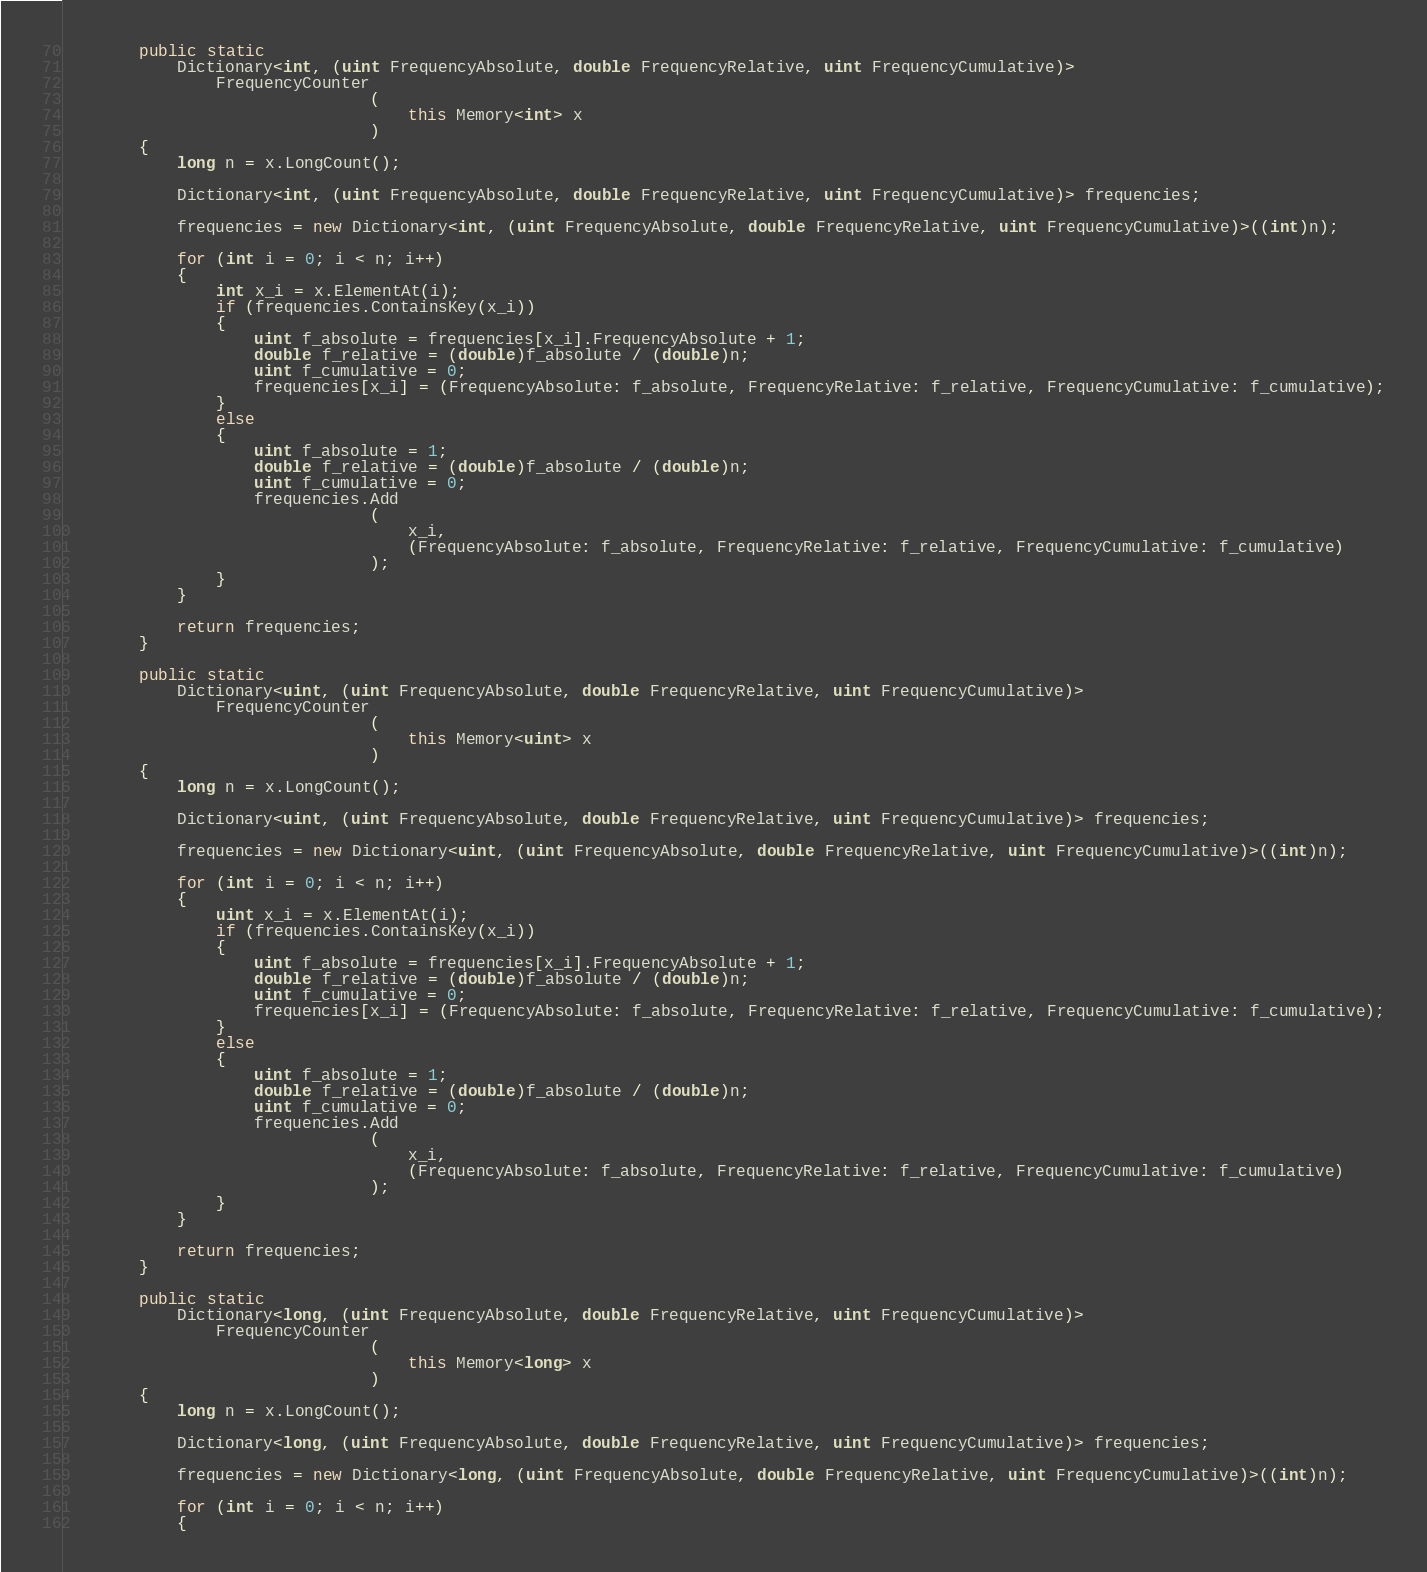Convert code to text. <code><loc_0><loc_0><loc_500><loc_500><_C#_>        public static
            Dictionary<int, (uint FrequencyAbsolute, double FrequencyRelative, uint FrequencyCumulative)>
                FrequencyCounter
                                (
                                    this Memory<int> x
                                )
        {
            long n = x.LongCount();

            Dictionary<int, (uint FrequencyAbsolute, double FrequencyRelative, uint FrequencyCumulative)> frequencies;

            frequencies = new Dictionary<int, (uint FrequencyAbsolute, double FrequencyRelative, uint FrequencyCumulative)>((int)n);

            for (int i = 0; i < n; i++)
            {
                int x_i = x.ElementAt(i);
                if (frequencies.ContainsKey(x_i))
                {
                    uint f_absolute = frequencies[x_i].FrequencyAbsolute + 1;
                    double f_relative = (double)f_absolute / (double)n;
                    uint f_cumulative = 0;
                    frequencies[x_i] = (FrequencyAbsolute: f_absolute, FrequencyRelative: f_relative, FrequencyCumulative: f_cumulative);
                }
                else
                {
                    uint f_absolute = 1;
                    double f_relative = (double)f_absolute / (double)n;
                    uint f_cumulative = 0;
                    frequencies.Add
                                (
                                    x_i,
                                    (FrequencyAbsolute: f_absolute, FrequencyRelative: f_relative, FrequencyCumulative: f_cumulative)
                                );
                }
            }

            return frequencies;
        }

        public static
            Dictionary<uint, (uint FrequencyAbsolute, double FrequencyRelative, uint FrequencyCumulative)>
                FrequencyCounter
                                (
                                    this Memory<uint> x
                                )
        {
            long n = x.LongCount();

            Dictionary<uint, (uint FrequencyAbsolute, double FrequencyRelative, uint FrequencyCumulative)> frequencies;

            frequencies = new Dictionary<uint, (uint FrequencyAbsolute, double FrequencyRelative, uint FrequencyCumulative)>((int)n);

            for (int i = 0; i < n; i++)
            {
                uint x_i = x.ElementAt(i);
                if (frequencies.ContainsKey(x_i))
                {
                    uint f_absolute = frequencies[x_i].FrequencyAbsolute + 1;
                    double f_relative = (double)f_absolute / (double)n;
                    uint f_cumulative = 0;
                    frequencies[x_i] = (FrequencyAbsolute: f_absolute, FrequencyRelative: f_relative, FrequencyCumulative: f_cumulative);
                }
                else
                {
                    uint f_absolute = 1;
                    double f_relative = (double)f_absolute / (double)n;
                    uint f_cumulative = 0;
                    frequencies.Add
                                (
                                    x_i,
                                    (FrequencyAbsolute: f_absolute, FrequencyRelative: f_relative, FrequencyCumulative: f_cumulative)
                                );
                }
            }

            return frequencies;
        }

        public static
            Dictionary<long, (uint FrequencyAbsolute, double FrequencyRelative, uint FrequencyCumulative)>
                FrequencyCounter
                                (
                                    this Memory<long> x
                                )
        {
            long n = x.LongCount();

            Dictionary<long, (uint FrequencyAbsolute, double FrequencyRelative, uint FrequencyCumulative)> frequencies;

            frequencies = new Dictionary<long, (uint FrequencyAbsolute, double FrequencyRelative, uint FrequencyCumulative)>((int)n);

            for (int i = 0; i < n; i++)
            {</code> 